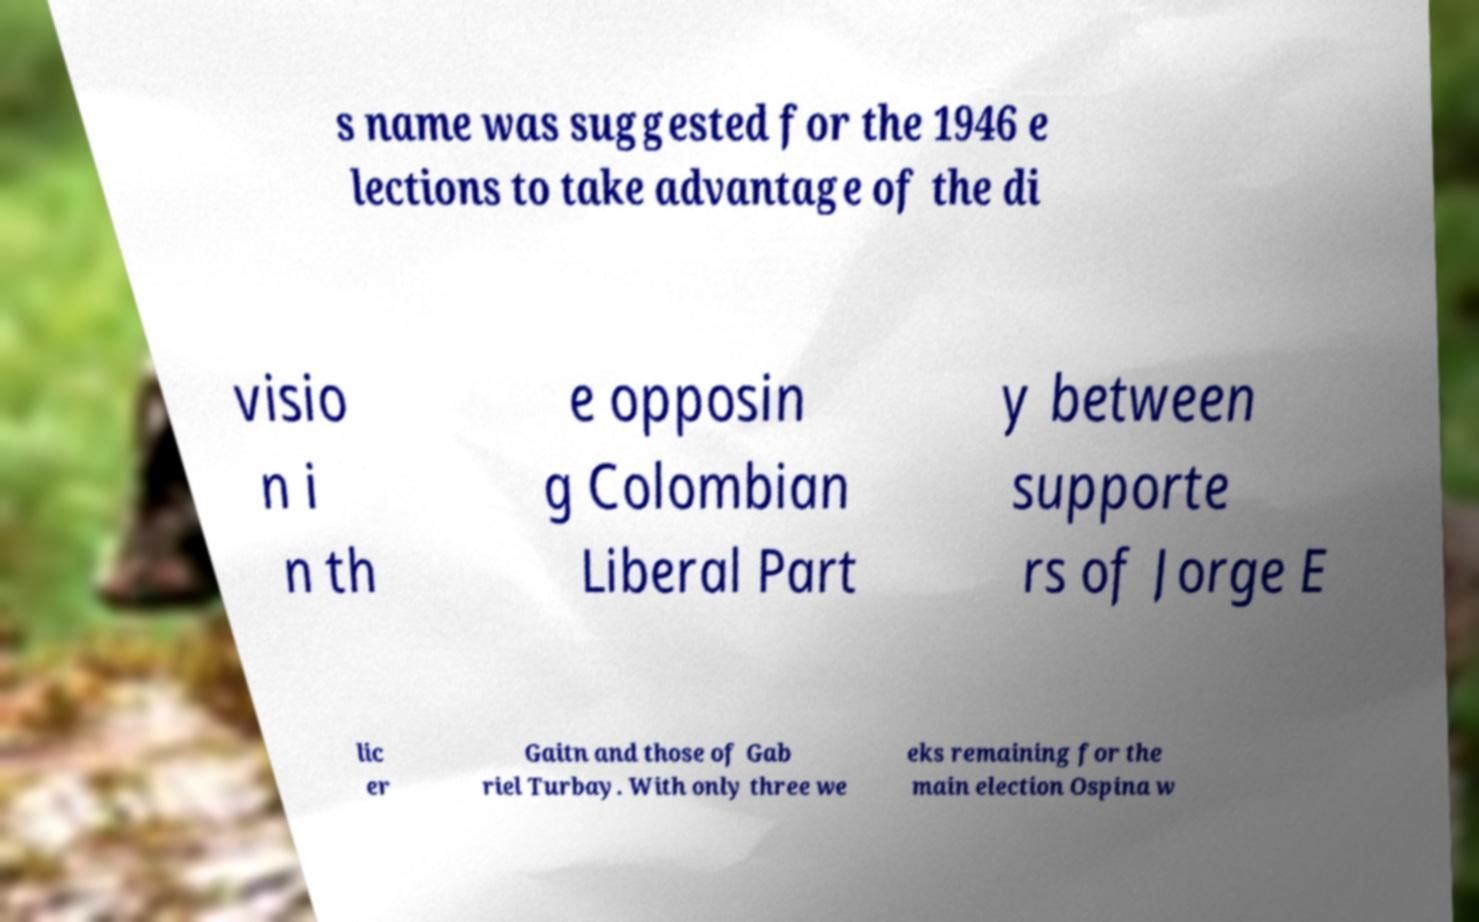Could you assist in decoding the text presented in this image and type it out clearly? s name was suggested for the 1946 e lections to take advantage of the di visio n i n th e opposin g Colombian Liberal Part y between supporte rs of Jorge E lic er Gaitn and those of Gab riel Turbay. With only three we eks remaining for the main election Ospina w 